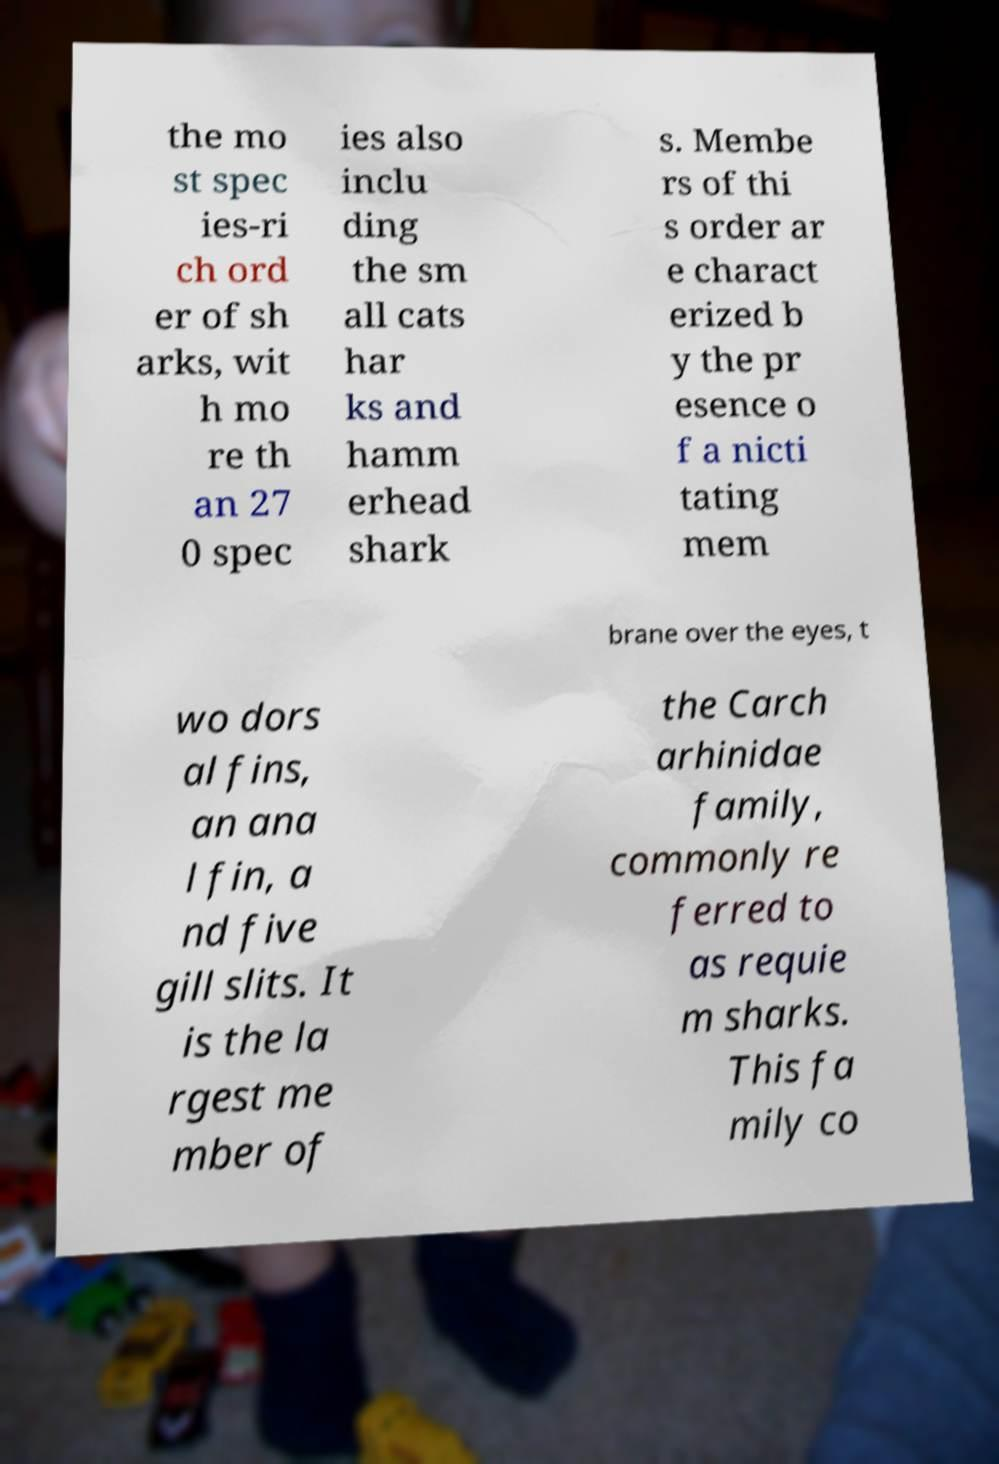Can you read and provide the text displayed in the image?This photo seems to have some interesting text. Can you extract and type it out for me? the mo st spec ies-ri ch ord er of sh arks, wit h mo re th an 27 0 spec ies also inclu ding the sm all cats har ks and hamm erhead shark s. Membe rs of thi s order ar e charact erized b y the pr esence o f a nicti tating mem brane over the eyes, t wo dors al fins, an ana l fin, a nd five gill slits. It is the la rgest me mber of the Carch arhinidae family, commonly re ferred to as requie m sharks. This fa mily co 